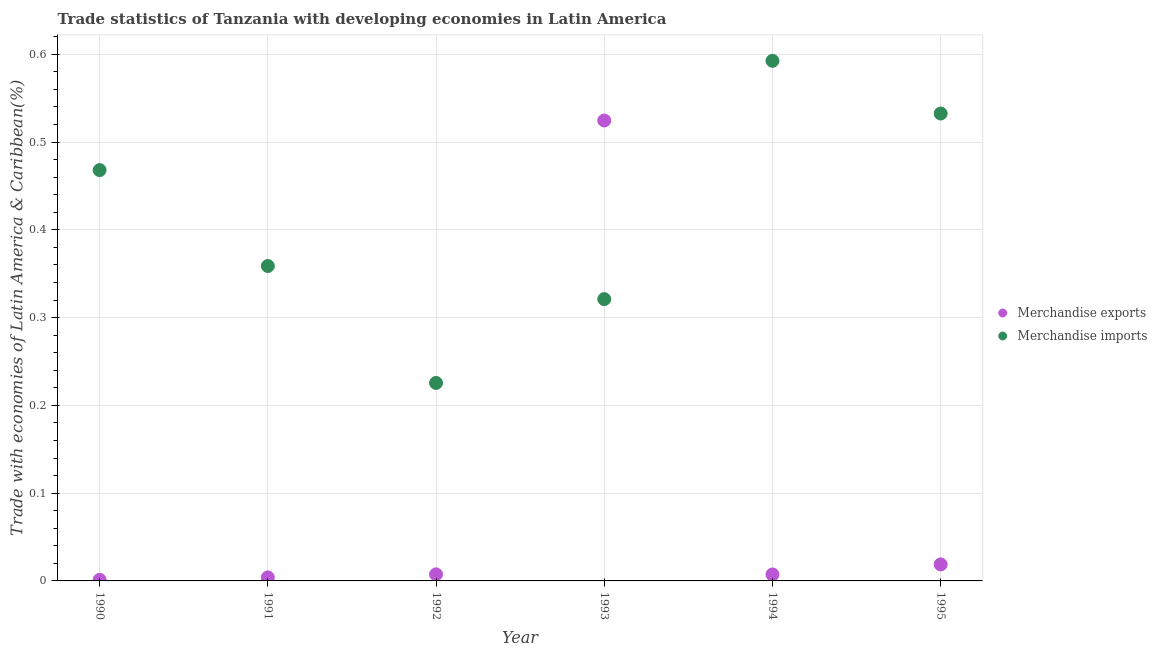Is the number of dotlines equal to the number of legend labels?
Provide a succinct answer. Yes. What is the merchandise imports in 1993?
Your answer should be compact. 0.32. Across all years, what is the maximum merchandise exports?
Make the answer very short. 0.52. Across all years, what is the minimum merchandise exports?
Provide a succinct answer. 0. In which year was the merchandise exports minimum?
Ensure brevity in your answer.  1990. What is the total merchandise imports in the graph?
Offer a terse response. 2.5. What is the difference between the merchandise exports in 1991 and that in 1993?
Give a very brief answer. -0.52. What is the difference between the merchandise exports in 1990 and the merchandise imports in 1992?
Offer a terse response. -0.22. What is the average merchandise exports per year?
Provide a short and direct response. 0.09. In the year 1994, what is the difference between the merchandise imports and merchandise exports?
Make the answer very short. 0.59. What is the ratio of the merchandise exports in 1990 to that in 1993?
Your response must be concise. 0. Is the merchandise imports in 1990 less than that in 1993?
Offer a very short reply. No. Is the difference between the merchandise exports in 1992 and 1994 greater than the difference between the merchandise imports in 1992 and 1994?
Offer a terse response. Yes. What is the difference between the highest and the second highest merchandise imports?
Make the answer very short. 0.06. What is the difference between the highest and the lowest merchandise exports?
Your answer should be compact. 0.52. In how many years, is the merchandise imports greater than the average merchandise imports taken over all years?
Make the answer very short. 3. Is the merchandise exports strictly less than the merchandise imports over the years?
Provide a succinct answer. No. How many dotlines are there?
Make the answer very short. 2. Are the values on the major ticks of Y-axis written in scientific E-notation?
Provide a succinct answer. No. Does the graph contain any zero values?
Your response must be concise. No. Where does the legend appear in the graph?
Provide a short and direct response. Center right. How are the legend labels stacked?
Make the answer very short. Vertical. What is the title of the graph?
Ensure brevity in your answer.  Trade statistics of Tanzania with developing economies in Latin America. Does "Revenue" appear as one of the legend labels in the graph?
Give a very brief answer. No. What is the label or title of the Y-axis?
Provide a succinct answer. Trade with economies of Latin America & Caribbean(%). What is the Trade with economies of Latin America & Caribbean(%) in Merchandise exports in 1990?
Make the answer very short. 0. What is the Trade with economies of Latin America & Caribbean(%) in Merchandise imports in 1990?
Keep it short and to the point. 0.47. What is the Trade with economies of Latin America & Caribbean(%) in Merchandise exports in 1991?
Provide a succinct answer. 0. What is the Trade with economies of Latin America & Caribbean(%) in Merchandise imports in 1991?
Provide a succinct answer. 0.36. What is the Trade with economies of Latin America & Caribbean(%) in Merchandise exports in 1992?
Provide a succinct answer. 0.01. What is the Trade with economies of Latin America & Caribbean(%) in Merchandise imports in 1992?
Your answer should be very brief. 0.23. What is the Trade with economies of Latin America & Caribbean(%) in Merchandise exports in 1993?
Ensure brevity in your answer.  0.52. What is the Trade with economies of Latin America & Caribbean(%) of Merchandise imports in 1993?
Give a very brief answer. 0.32. What is the Trade with economies of Latin America & Caribbean(%) of Merchandise exports in 1994?
Offer a very short reply. 0.01. What is the Trade with economies of Latin America & Caribbean(%) of Merchandise imports in 1994?
Offer a very short reply. 0.59. What is the Trade with economies of Latin America & Caribbean(%) in Merchandise exports in 1995?
Make the answer very short. 0.02. What is the Trade with economies of Latin America & Caribbean(%) in Merchandise imports in 1995?
Provide a short and direct response. 0.53. Across all years, what is the maximum Trade with economies of Latin America & Caribbean(%) of Merchandise exports?
Your response must be concise. 0.52. Across all years, what is the maximum Trade with economies of Latin America & Caribbean(%) of Merchandise imports?
Provide a short and direct response. 0.59. Across all years, what is the minimum Trade with economies of Latin America & Caribbean(%) in Merchandise exports?
Provide a succinct answer. 0. Across all years, what is the minimum Trade with economies of Latin America & Caribbean(%) in Merchandise imports?
Your answer should be very brief. 0.23. What is the total Trade with economies of Latin America & Caribbean(%) of Merchandise exports in the graph?
Keep it short and to the point. 0.56. What is the total Trade with economies of Latin America & Caribbean(%) of Merchandise imports in the graph?
Provide a succinct answer. 2.5. What is the difference between the Trade with economies of Latin America & Caribbean(%) of Merchandise exports in 1990 and that in 1991?
Your answer should be compact. -0. What is the difference between the Trade with economies of Latin America & Caribbean(%) of Merchandise imports in 1990 and that in 1991?
Your answer should be very brief. 0.11. What is the difference between the Trade with economies of Latin America & Caribbean(%) of Merchandise exports in 1990 and that in 1992?
Keep it short and to the point. -0.01. What is the difference between the Trade with economies of Latin America & Caribbean(%) of Merchandise imports in 1990 and that in 1992?
Make the answer very short. 0.24. What is the difference between the Trade with economies of Latin America & Caribbean(%) in Merchandise exports in 1990 and that in 1993?
Your answer should be very brief. -0.52. What is the difference between the Trade with economies of Latin America & Caribbean(%) of Merchandise imports in 1990 and that in 1993?
Give a very brief answer. 0.15. What is the difference between the Trade with economies of Latin America & Caribbean(%) of Merchandise exports in 1990 and that in 1994?
Keep it short and to the point. -0.01. What is the difference between the Trade with economies of Latin America & Caribbean(%) of Merchandise imports in 1990 and that in 1994?
Provide a succinct answer. -0.12. What is the difference between the Trade with economies of Latin America & Caribbean(%) of Merchandise exports in 1990 and that in 1995?
Ensure brevity in your answer.  -0.02. What is the difference between the Trade with economies of Latin America & Caribbean(%) of Merchandise imports in 1990 and that in 1995?
Provide a short and direct response. -0.06. What is the difference between the Trade with economies of Latin America & Caribbean(%) in Merchandise exports in 1991 and that in 1992?
Offer a very short reply. -0. What is the difference between the Trade with economies of Latin America & Caribbean(%) in Merchandise imports in 1991 and that in 1992?
Ensure brevity in your answer.  0.13. What is the difference between the Trade with economies of Latin America & Caribbean(%) of Merchandise exports in 1991 and that in 1993?
Your answer should be compact. -0.52. What is the difference between the Trade with economies of Latin America & Caribbean(%) in Merchandise imports in 1991 and that in 1993?
Offer a very short reply. 0.04. What is the difference between the Trade with economies of Latin America & Caribbean(%) in Merchandise exports in 1991 and that in 1994?
Your answer should be compact. -0. What is the difference between the Trade with economies of Latin America & Caribbean(%) of Merchandise imports in 1991 and that in 1994?
Make the answer very short. -0.23. What is the difference between the Trade with economies of Latin America & Caribbean(%) in Merchandise exports in 1991 and that in 1995?
Ensure brevity in your answer.  -0.01. What is the difference between the Trade with economies of Latin America & Caribbean(%) of Merchandise imports in 1991 and that in 1995?
Offer a terse response. -0.17. What is the difference between the Trade with economies of Latin America & Caribbean(%) of Merchandise exports in 1992 and that in 1993?
Your response must be concise. -0.52. What is the difference between the Trade with economies of Latin America & Caribbean(%) in Merchandise imports in 1992 and that in 1993?
Ensure brevity in your answer.  -0.1. What is the difference between the Trade with economies of Latin America & Caribbean(%) in Merchandise imports in 1992 and that in 1994?
Keep it short and to the point. -0.37. What is the difference between the Trade with economies of Latin America & Caribbean(%) of Merchandise exports in 1992 and that in 1995?
Provide a succinct answer. -0.01. What is the difference between the Trade with economies of Latin America & Caribbean(%) in Merchandise imports in 1992 and that in 1995?
Give a very brief answer. -0.31. What is the difference between the Trade with economies of Latin America & Caribbean(%) in Merchandise exports in 1993 and that in 1994?
Provide a succinct answer. 0.52. What is the difference between the Trade with economies of Latin America & Caribbean(%) in Merchandise imports in 1993 and that in 1994?
Your answer should be very brief. -0.27. What is the difference between the Trade with economies of Latin America & Caribbean(%) in Merchandise exports in 1993 and that in 1995?
Your answer should be very brief. 0.51. What is the difference between the Trade with economies of Latin America & Caribbean(%) of Merchandise imports in 1993 and that in 1995?
Make the answer very short. -0.21. What is the difference between the Trade with economies of Latin America & Caribbean(%) in Merchandise exports in 1994 and that in 1995?
Provide a short and direct response. -0.01. What is the difference between the Trade with economies of Latin America & Caribbean(%) of Merchandise imports in 1994 and that in 1995?
Your response must be concise. 0.06. What is the difference between the Trade with economies of Latin America & Caribbean(%) in Merchandise exports in 1990 and the Trade with economies of Latin America & Caribbean(%) in Merchandise imports in 1991?
Provide a succinct answer. -0.36. What is the difference between the Trade with economies of Latin America & Caribbean(%) of Merchandise exports in 1990 and the Trade with economies of Latin America & Caribbean(%) of Merchandise imports in 1992?
Your response must be concise. -0.22. What is the difference between the Trade with economies of Latin America & Caribbean(%) of Merchandise exports in 1990 and the Trade with economies of Latin America & Caribbean(%) of Merchandise imports in 1993?
Your response must be concise. -0.32. What is the difference between the Trade with economies of Latin America & Caribbean(%) in Merchandise exports in 1990 and the Trade with economies of Latin America & Caribbean(%) in Merchandise imports in 1994?
Your response must be concise. -0.59. What is the difference between the Trade with economies of Latin America & Caribbean(%) of Merchandise exports in 1990 and the Trade with economies of Latin America & Caribbean(%) of Merchandise imports in 1995?
Provide a short and direct response. -0.53. What is the difference between the Trade with economies of Latin America & Caribbean(%) of Merchandise exports in 1991 and the Trade with economies of Latin America & Caribbean(%) of Merchandise imports in 1992?
Give a very brief answer. -0.22. What is the difference between the Trade with economies of Latin America & Caribbean(%) of Merchandise exports in 1991 and the Trade with economies of Latin America & Caribbean(%) of Merchandise imports in 1993?
Your response must be concise. -0.32. What is the difference between the Trade with economies of Latin America & Caribbean(%) in Merchandise exports in 1991 and the Trade with economies of Latin America & Caribbean(%) in Merchandise imports in 1994?
Provide a succinct answer. -0.59. What is the difference between the Trade with economies of Latin America & Caribbean(%) of Merchandise exports in 1991 and the Trade with economies of Latin America & Caribbean(%) of Merchandise imports in 1995?
Your answer should be compact. -0.53. What is the difference between the Trade with economies of Latin America & Caribbean(%) in Merchandise exports in 1992 and the Trade with economies of Latin America & Caribbean(%) in Merchandise imports in 1993?
Offer a very short reply. -0.31. What is the difference between the Trade with economies of Latin America & Caribbean(%) of Merchandise exports in 1992 and the Trade with economies of Latin America & Caribbean(%) of Merchandise imports in 1994?
Make the answer very short. -0.58. What is the difference between the Trade with economies of Latin America & Caribbean(%) of Merchandise exports in 1992 and the Trade with economies of Latin America & Caribbean(%) of Merchandise imports in 1995?
Give a very brief answer. -0.53. What is the difference between the Trade with economies of Latin America & Caribbean(%) of Merchandise exports in 1993 and the Trade with economies of Latin America & Caribbean(%) of Merchandise imports in 1994?
Give a very brief answer. -0.07. What is the difference between the Trade with economies of Latin America & Caribbean(%) of Merchandise exports in 1993 and the Trade with economies of Latin America & Caribbean(%) of Merchandise imports in 1995?
Your answer should be compact. -0.01. What is the difference between the Trade with economies of Latin America & Caribbean(%) of Merchandise exports in 1994 and the Trade with economies of Latin America & Caribbean(%) of Merchandise imports in 1995?
Give a very brief answer. -0.53. What is the average Trade with economies of Latin America & Caribbean(%) of Merchandise exports per year?
Your answer should be very brief. 0.09. What is the average Trade with economies of Latin America & Caribbean(%) in Merchandise imports per year?
Offer a very short reply. 0.42. In the year 1990, what is the difference between the Trade with economies of Latin America & Caribbean(%) in Merchandise exports and Trade with economies of Latin America & Caribbean(%) in Merchandise imports?
Ensure brevity in your answer.  -0.47. In the year 1991, what is the difference between the Trade with economies of Latin America & Caribbean(%) in Merchandise exports and Trade with economies of Latin America & Caribbean(%) in Merchandise imports?
Offer a terse response. -0.35. In the year 1992, what is the difference between the Trade with economies of Latin America & Caribbean(%) of Merchandise exports and Trade with economies of Latin America & Caribbean(%) of Merchandise imports?
Your response must be concise. -0.22. In the year 1993, what is the difference between the Trade with economies of Latin America & Caribbean(%) in Merchandise exports and Trade with economies of Latin America & Caribbean(%) in Merchandise imports?
Provide a short and direct response. 0.2. In the year 1994, what is the difference between the Trade with economies of Latin America & Caribbean(%) in Merchandise exports and Trade with economies of Latin America & Caribbean(%) in Merchandise imports?
Provide a short and direct response. -0.59. In the year 1995, what is the difference between the Trade with economies of Latin America & Caribbean(%) in Merchandise exports and Trade with economies of Latin America & Caribbean(%) in Merchandise imports?
Offer a terse response. -0.51. What is the ratio of the Trade with economies of Latin America & Caribbean(%) in Merchandise exports in 1990 to that in 1991?
Your response must be concise. 0.31. What is the ratio of the Trade with economies of Latin America & Caribbean(%) of Merchandise imports in 1990 to that in 1991?
Provide a succinct answer. 1.3. What is the ratio of the Trade with economies of Latin America & Caribbean(%) of Merchandise exports in 1990 to that in 1992?
Make the answer very short. 0.17. What is the ratio of the Trade with economies of Latin America & Caribbean(%) in Merchandise imports in 1990 to that in 1992?
Make the answer very short. 2.07. What is the ratio of the Trade with economies of Latin America & Caribbean(%) in Merchandise exports in 1990 to that in 1993?
Offer a terse response. 0. What is the ratio of the Trade with economies of Latin America & Caribbean(%) in Merchandise imports in 1990 to that in 1993?
Provide a short and direct response. 1.46. What is the ratio of the Trade with economies of Latin America & Caribbean(%) in Merchandise exports in 1990 to that in 1994?
Give a very brief answer. 0.17. What is the ratio of the Trade with economies of Latin America & Caribbean(%) of Merchandise imports in 1990 to that in 1994?
Keep it short and to the point. 0.79. What is the ratio of the Trade with economies of Latin America & Caribbean(%) in Merchandise exports in 1990 to that in 1995?
Offer a terse response. 0.07. What is the ratio of the Trade with economies of Latin America & Caribbean(%) of Merchandise imports in 1990 to that in 1995?
Give a very brief answer. 0.88. What is the ratio of the Trade with economies of Latin America & Caribbean(%) in Merchandise exports in 1991 to that in 1992?
Ensure brevity in your answer.  0.54. What is the ratio of the Trade with economies of Latin America & Caribbean(%) of Merchandise imports in 1991 to that in 1992?
Your answer should be very brief. 1.59. What is the ratio of the Trade with economies of Latin America & Caribbean(%) of Merchandise exports in 1991 to that in 1993?
Offer a terse response. 0.01. What is the ratio of the Trade with economies of Latin America & Caribbean(%) in Merchandise imports in 1991 to that in 1993?
Your response must be concise. 1.12. What is the ratio of the Trade with economies of Latin America & Caribbean(%) of Merchandise exports in 1991 to that in 1994?
Your response must be concise. 0.55. What is the ratio of the Trade with economies of Latin America & Caribbean(%) of Merchandise imports in 1991 to that in 1994?
Provide a succinct answer. 0.61. What is the ratio of the Trade with economies of Latin America & Caribbean(%) in Merchandise exports in 1991 to that in 1995?
Your answer should be very brief. 0.21. What is the ratio of the Trade with economies of Latin America & Caribbean(%) in Merchandise imports in 1991 to that in 1995?
Provide a short and direct response. 0.67. What is the ratio of the Trade with economies of Latin America & Caribbean(%) of Merchandise exports in 1992 to that in 1993?
Make the answer very short. 0.01. What is the ratio of the Trade with economies of Latin America & Caribbean(%) of Merchandise imports in 1992 to that in 1993?
Keep it short and to the point. 0.7. What is the ratio of the Trade with economies of Latin America & Caribbean(%) of Merchandise exports in 1992 to that in 1994?
Provide a short and direct response. 1.02. What is the ratio of the Trade with economies of Latin America & Caribbean(%) of Merchandise imports in 1992 to that in 1994?
Make the answer very short. 0.38. What is the ratio of the Trade with economies of Latin America & Caribbean(%) in Merchandise exports in 1992 to that in 1995?
Your answer should be very brief. 0.4. What is the ratio of the Trade with economies of Latin America & Caribbean(%) of Merchandise imports in 1992 to that in 1995?
Offer a terse response. 0.42. What is the ratio of the Trade with economies of Latin America & Caribbean(%) in Merchandise exports in 1993 to that in 1994?
Make the answer very short. 71.4. What is the ratio of the Trade with economies of Latin America & Caribbean(%) in Merchandise imports in 1993 to that in 1994?
Your answer should be very brief. 0.54. What is the ratio of the Trade with economies of Latin America & Caribbean(%) of Merchandise exports in 1993 to that in 1995?
Your answer should be very brief. 27.86. What is the ratio of the Trade with economies of Latin America & Caribbean(%) in Merchandise imports in 1993 to that in 1995?
Offer a very short reply. 0.6. What is the ratio of the Trade with economies of Latin America & Caribbean(%) in Merchandise exports in 1994 to that in 1995?
Give a very brief answer. 0.39. What is the ratio of the Trade with economies of Latin America & Caribbean(%) of Merchandise imports in 1994 to that in 1995?
Ensure brevity in your answer.  1.11. What is the difference between the highest and the second highest Trade with economies of Latin America & Caribbean(%) of Merchandise exports?
Ensure brevity in your answer.  0.51. What is the difference between the highest and the second highest Trade with economies of Latin America & Caribbean(%) of Merchandise imports?
Your answer should be compact. 0.06. What is the difference between the highest and the lowest Trade with economies of Latin America & Caribbean(%) in Merchandise exports?
Give a very brief answer. 0.52. What is the difference between the highest and the lowest Trade with economies of Latin America & Caribbean(%) in Merchandise imports?
Give a very brief answer. 0.37. 